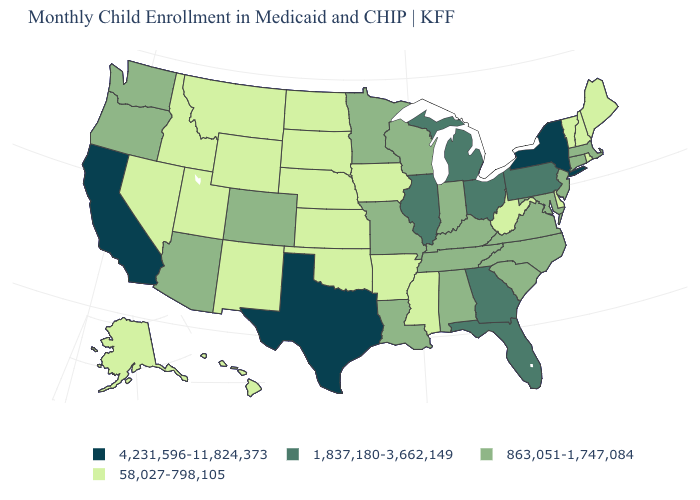Does California have the highest value in the West?
Quick response, please. Yes. What is the value of Wyoming?
Quick response, please. 58,027-798,105. What is the lowest value in the USA?
Keep it brief. 58,027-798,105. Does New York have the highest value in the USA?
Concise answer only. Yes. Name the states that have a value in the range 863,051-1,747,084?
Be succinct. Alabama, Arizona, Colorado, Connecticut, Indiana, Kentucky, Louisiana, Maryland, Massachusetts, Minnesota, Missouri, New Jersey, North Carolina, Oregon, South Carolina, Tennessee, Virginia, Washington, Wisconsin. What is the value of North Dakota?
Concise answer only. 58,027-798,105. What is the lowest value in the USA?
Quick response, please. 58,027-798,105. What is the highest value in states that border Indiana?
Be succinct. 1,837,180-3,662,149. What is the value of Wisconsin?
Quick response, please. 863,051-1,747,084. Which states have the highest value in the USA?
Quick response, please. California, New York, Texas. What is the value of Pennsylvania?
Write a very short answer. 1,837,180-3,662,149. Among the states that border Virginia , does West Virginia have the lowest value?
Answer briefly. Yes. How many symbols are there in the legend?
Answer briefly. 4. Does the map have missing data?
Answer briefly. No. What is the highest value in the MidWest ?
Answer briefly. 1,837,180-3,662,149. 